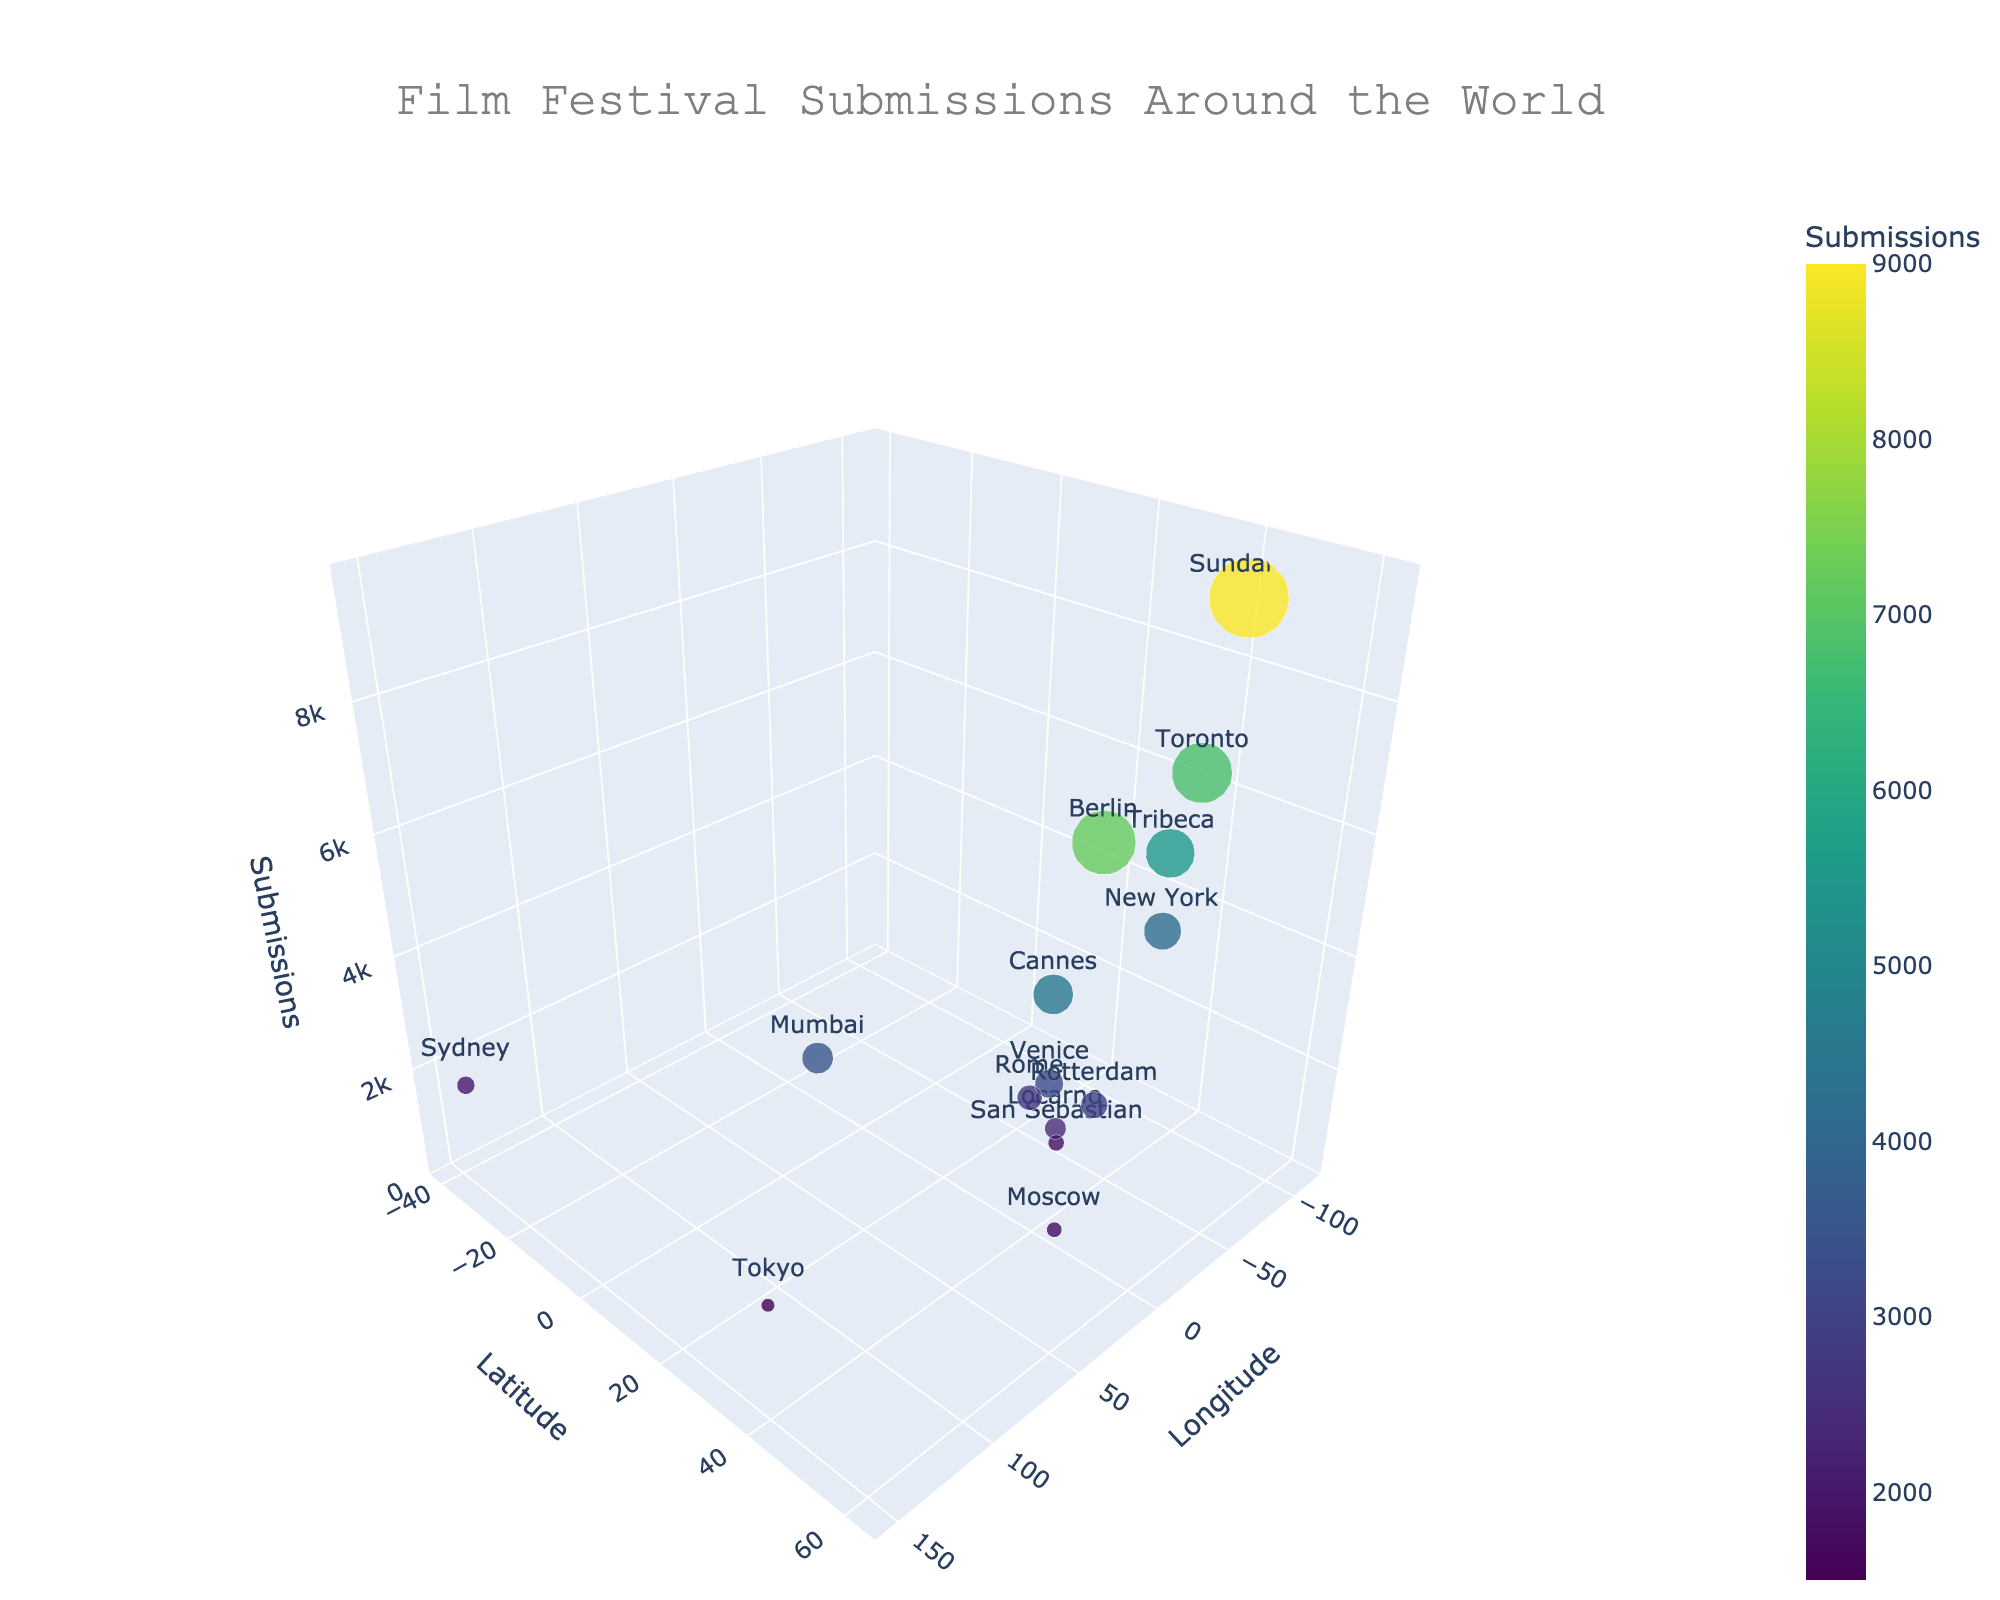What is the title of the figure? The title of the figure is usually placed at the top and is the largest text, often centered.
Answer: Film Festival Submissions Around the World Which city has the highest number of submissions? To find the city with the highest number of submissions, look for the largest bubble along the z-axis where the submission count is highest.
Answer: Sundance What is the color scale representing in the figure? The color scale is used to represent a specific variable, usually indicated by a color bar. In this figure, it's for the number of submissions.
Answer: Number of submissions Which country has the most film festival submissions combined? Sum the submissions for cities within each country and compare them.
Answer: USA Which film festival has fewer submissions, Locarno or Tokyo? Compare the size and position of the bubbles along the z-axis for Locarno and Tokyo.
Answer: Tokyo How many submissions are there in Venice? Identify the bubble for Venice and read its value on the z-axis or from the tooltip.
Answer: 3200 Which city on the chart has approximately equal submissions to Sydney? Find Sydney’s bubble and look for another bubble of similar size and corresponding z value.
Answer: Moscow What is the average number of submissions for cities in Italy? Add submissions for Venice (3200) and Rome (2800), then divide by the number of cities (2).
Answer: 3000 Which two cities are closest to each other in terms of latitude and longitude? Compare the coordinates (latitude and longitude) of all cities to find the closest pair. One easy pair to spot is Tribeca and New York as they are very close geographically.
Answer: Tribeca and New York Are there more submissions for Tribeca or New York? Compare the bubble sizes and z values for Tribeca and New York directly.
Answer: Tribeca 